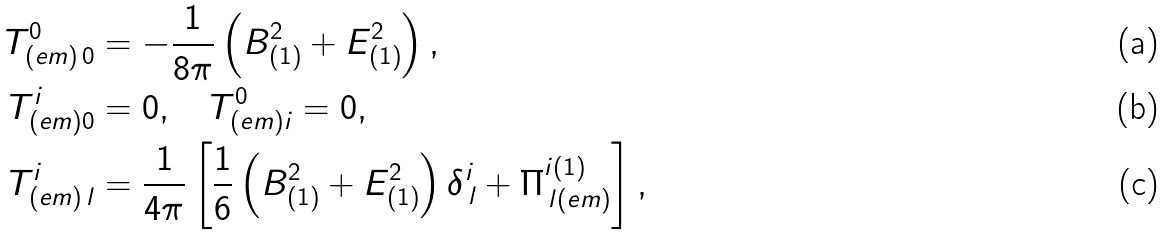<formula> <loc_0><loc_0><loc_500><loc_500>T _ { ( e m ) \, 0 } ^ { 0 } & = - \frac { 1 } { 8 \pi } \left ( { B } _ { ( 1 ) } ^ { 2 } + { E } _ { ( 1 ) } ^ { 2 } \right ) , \\ T _ { ( e m ) 0 } ^ { i } & = 0 , \quad T _ { ( e m ) i } ^ { 0 } = 0 , \\ T _ { ( e m ) \, l } ^ { i } & = \frac { 1 } { 4 \pi } \left [ \frac { 1 } { 6 } \left ( { B } _ { ( 1 ) } ^ { 2 } + { E } _ { ( 1 ) } ^ { 2 } \right ) \delta _ { \, l } ^ { i } + \Pi _ { \, l ( e m ) } ^ { i ( 1 ) } \right ] ,</formula> 